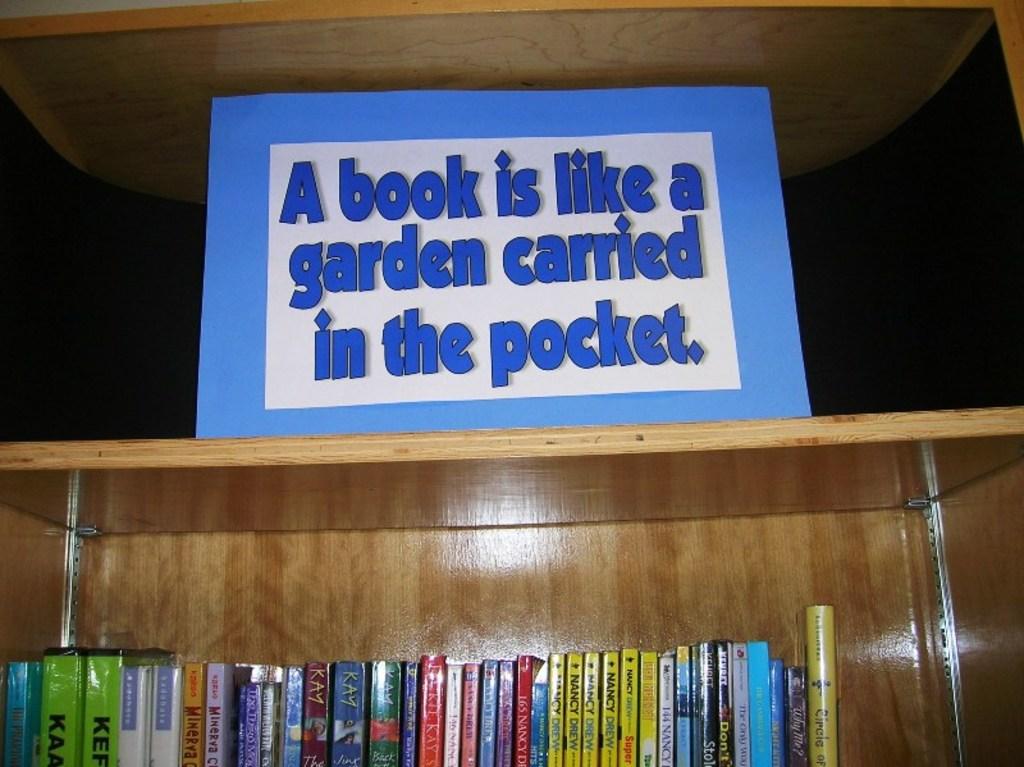Do you are or disagree with that statement?
Provide a short and direct response. Agree. Do you think a book is like a garden?
Make the answer very short. Answering does not require reading text in the image. 